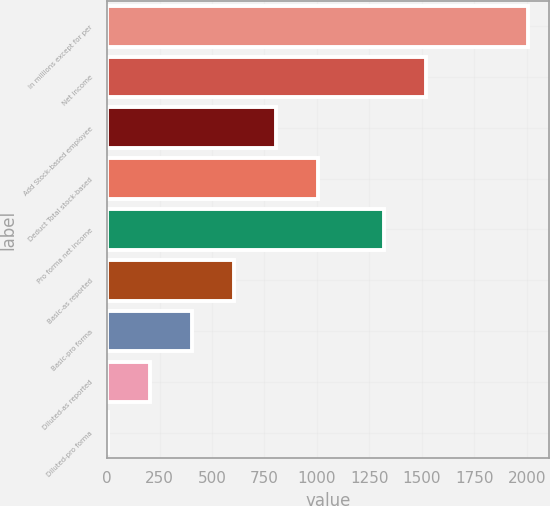Convert chart to OTSL. <chart><loc_0><loc_0><loc_500><loc_500><bar_chart><fcel>In millions except for per<fcel>Net income<fcel>Add Stock-based employee<fcel>Deduct Total stock-based<fcel>Pro forma net income<fcel>Basic-as reported<fcel>Basic-pro forma<fcel>Diluted-as reported<fcel>Diluted-pro forma<nl><fcel>2005<fcel>1519.05<fcel>804.72<fcel>1004.77<fcel>1319<fcel>604.67<fcel>404.62<fcel>204.57<fcel>4.52<nl></chart> 